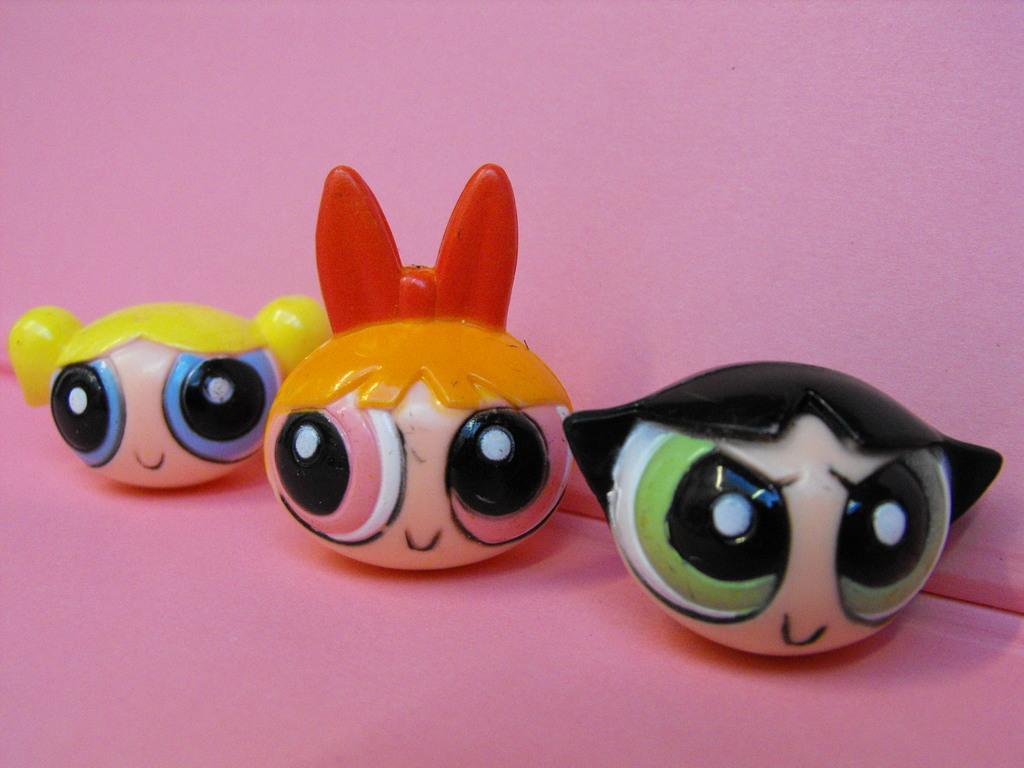Describe this image in one or two sentences. In this picture we can see toy faces on a platform and we can see a wall in the background. 